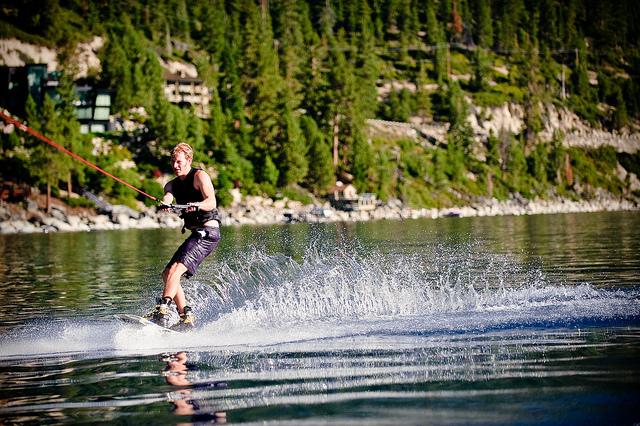Who is pulling him?
Keep it brief. Boat. Are there waves?
Answer briefly. Yes. Are there trees in the image?
Keep it brief. Yes. 